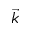<formula> <loc_0><loc_0><loc_500><loc_500>\vec { k }</formula> 